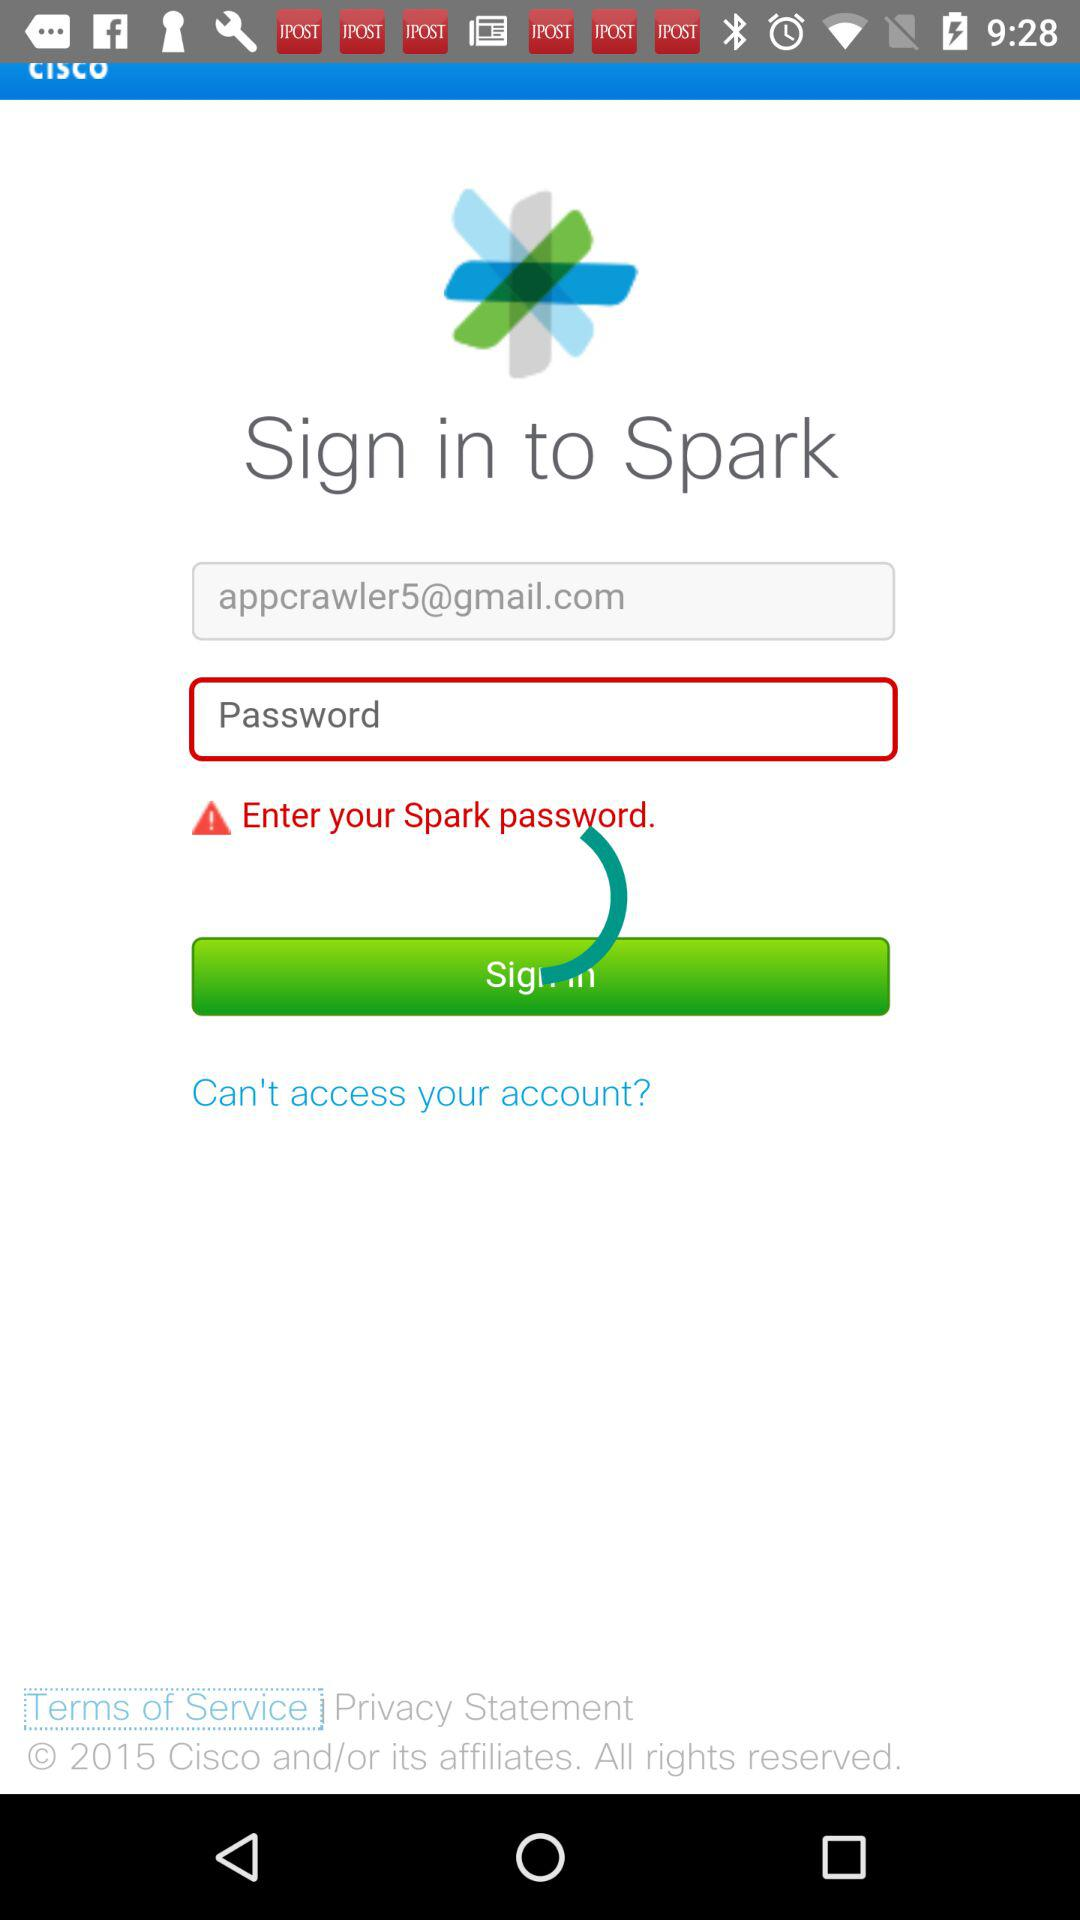What is the name of the application? The name of the application is "Spark". 